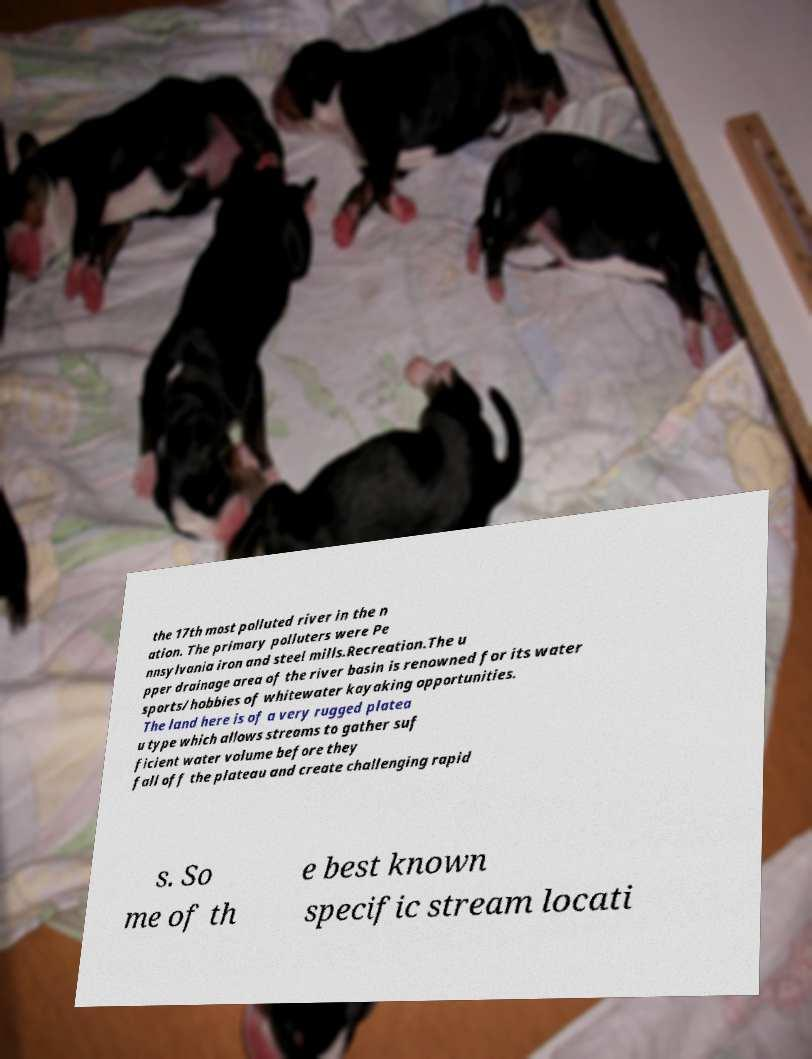What messages or text are displayed in this image? I need them in a readable, typed format. the 17th most polluted river in the n ation. The primary polluters were Pe nnsylvania iron and steel mills.Recreation.The u pper drainage area of the river basin is renowned for its water sports/hobbies of whitewater kayaking opportunities. The land here is of a very rugged platea u type which allows streams to gather suf ficient water volume before they fall off the plateau and create challenging rapid s. So me of th e best known specific stream locati 